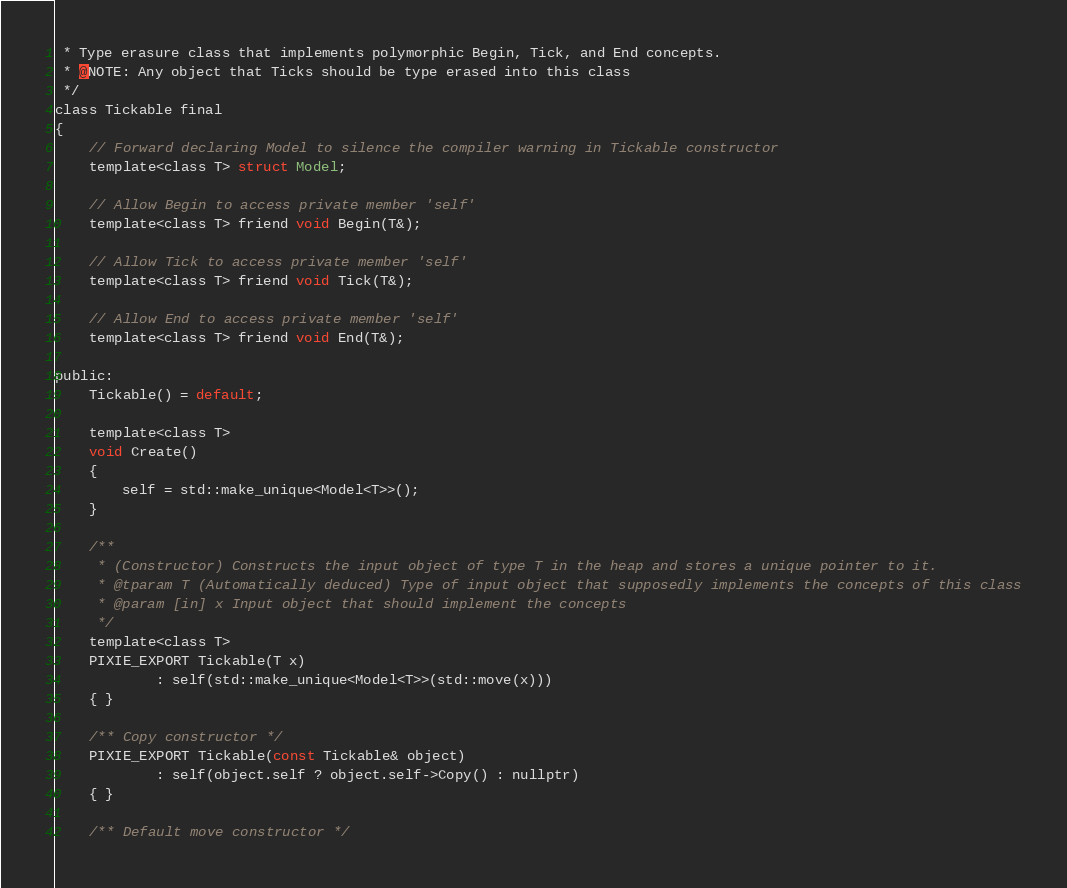Convert code to text. <code><loc_0><loc_0><loc_500><loc_500><_C_> * Type erasure class that implements polymorphic Begin, Tick, and End concepts.
 * @NOTE: Any object that Ticks should be type erased into this class
 */
class Tickable final
{
	// Forward declaring Model to silence the compiler warning in Tickable constructor
	template<class T> struct Model;

	// Allow Begin to access private member 'self'
	template<class T> friend void Begin(T&);

	// Allow Tick to access private member 'self'
	template<class T> friend void Tick(T&);

	// Allow End to access private member 'self'
	template<class T> friend void End(T&);

public:
	Tickable() = default;

	template<class T>
	void Create()
	{
		self = std::make_unique<Model<T>>();
	}

	/**
	 * (Constructor) Constructs the input object of type T in the heap and stores a unique pointer to it.
	 * @tparam T (Automatically deduced) Type of input object that supposedly implements the concepts of this class
	 * @param [in] x Input object that should implement the concepts
	 */
	template<class T>
	PIXIE_EXPORT Tickable(T x)
			: self(std::make_unique<Model<T>>(std::move(x)))
	{ }

	/** Copy constructor */
	PIXIE_EXPORT Tickable(const Tickable& object)
			: self(object.self ? object.self->Copy() : nullptr)
	{ }

	/** Default move constructor */</code> 